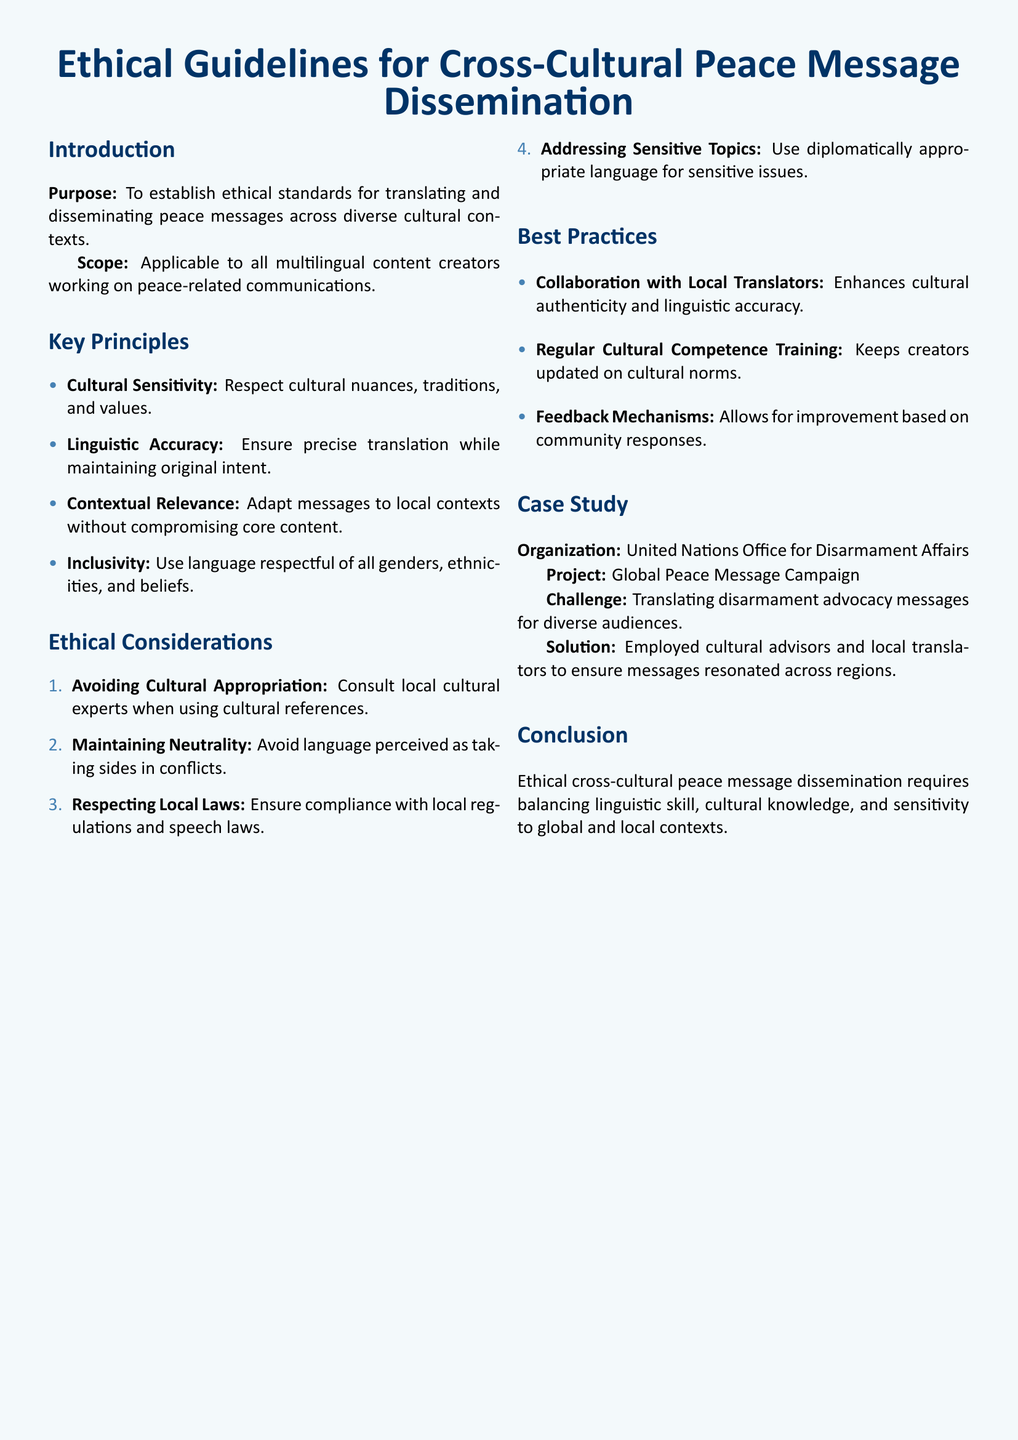What is the purpose of the document? The purpose is to establish ethical standards for translating and disseminating peace messages across diverse cultural contexts.
Answer: To establish ethical standards for translating and disseminating peace messages across diverse cultural contexts Who is the intended audience for this document? The intended audience comprises all multilingual content creators working on peace-related communications.
Answer: All multilingual content creators What is the first key principle outlined? The first key principle listed is about respecting cultural nuances, traditions, and values.
Answer: Cultural Sensitivity How many ethical considerations are specified in the document? The document specifies a total of four ethical considerations.
Answer: Four Which organization is featured in the case study? The organization highlighted in the case study is the United Nations Office for Disarmament Affairs.
Answer: United Nations Office for Disarmament Affairs What is one recommended best practice mentioned? One recommended best practice is collaboration with local translators to enhance cultural authenticity and linguistic accuracy.
Answer: Collaboration with Local Translators What is the primary challenge faced by the organization in the case study? The primary challenge was translating disarmament advocacy messages for diverse audiences.
Answer: Translating disarmament advocacy messages What type of training is suggested for content creators? Regular cultural competence training is suggested to keep creators updated on cultural norms.
Answer: Regular cultural competence training 